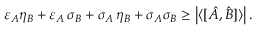<formula> <loc_0><loc_0><loc_500><loc_500>\varepsilon _ { A } \eta _ { B } + \varepsilon _ { A } \, \sigma _ { B } + \sigma _ { A } \, \eta _ { B } + \sigma _ { A } \sigma _ { B } \geq \left | \langle [ { \hat { A } } , { \hat { B } } ] \rangle \right | .</formula> 